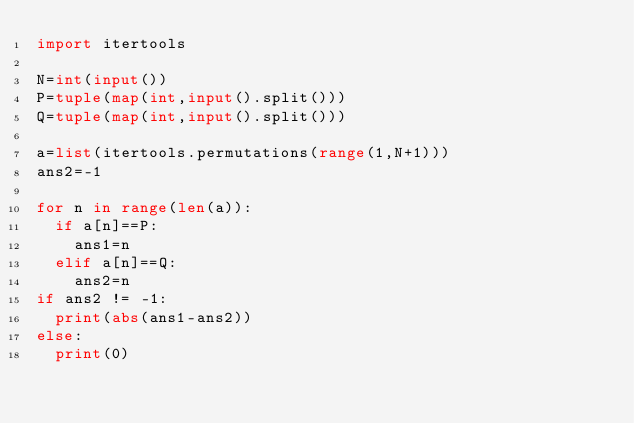<code> <loc_0><loc_0><loc_500><loc_500><_Python_>import itertools

N=int(input())
P=tuple(map(int,input().split()))
Q=tuple(map(int,input().split()))

a=list(itertools.permutations(range(1,N+1)))
ans2=-1

for n in range(len(a)):
  if a[n]==P:
    ans1=n
  elif a[n]==Q:
    ans2=n
if ans2 != -1:
  print(abs(ans1-ans2))
else:
  print(0)</code> 